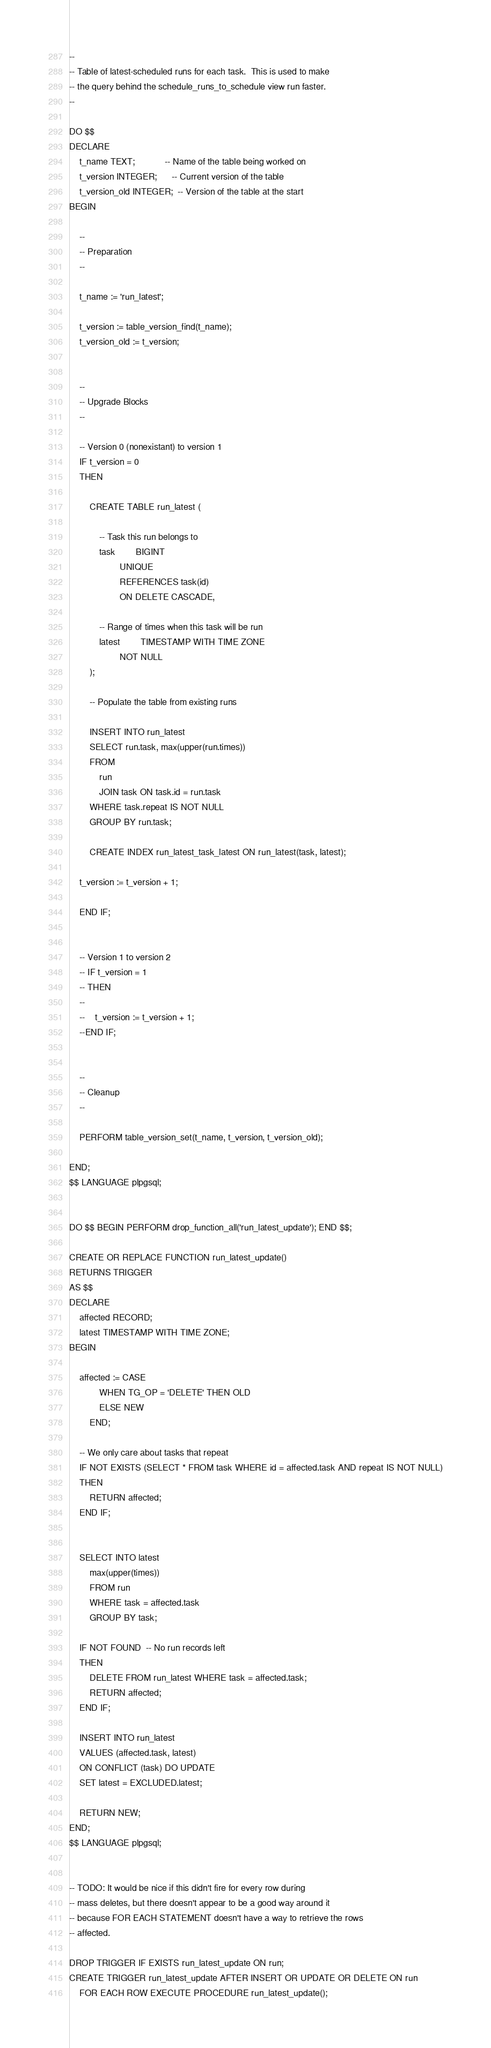Convert code to text. <code><loc_0><loc_0><loc_500><loc_500><_SQL_>--
-- Table of latest-scheduled runs for each task.  This is used to make
-- the query behind the schedule_runs_to_schedule view run faster.
--

DO $$
DECLARE
    t_name TEXT;            -- Name of the table being worked on
    t_version INTEGER;      -- Current version of the table
    t_version_old INTEGER;  -- Version of the table at the start
BEGIN

    --
    -- Preparation
    --

    t_name := 'run_latest';

    t_version := table_version_find(t_name);
    t_version_old := t_version;


    --
    -- Upgrade Blocks
    --

    -- Version 0 (nonexistant) to version 1
    IF t_version = 0
    THEN

        CREATE TABLE run_latest (

        	-- Task this run belongs to
        	task		BIGINT
        			UNIQUE
        			REFERENCES task(id)
        			ON DELETE CASCADE,

        	-- Range of times when this task will be run
        	latest		TIMESTAMP WITH TIME ZONE
        			NOT NULL
        );

        -- Populate the table from existing runs

        INSERT INTO run_latest
        SELECT run.task, max(upper(run.times))
        FROM
            run
            JOIN task ON task.id = run.task
        WHERE task.repeat IS NOT NULL
        GROUP BY run.task;

        CREATE INDEX run_latest_task_latest ON run_latest(task, latest);

	t_version := t_version + 1;

    END IF;


    -- Version 1 to version 2
    -- IF t_version = 1
    -- THEN
    --
    --    t_version := t_version + 1;
    --END IF;


    --
    -- Cleanup
    --

    PERFORM table_version_set(t_name, t_version, t_version_old);

END;
$$ LANGUAGE plpgsql;


DO $$ BEGIN PERFORM drop_function_all('run_latest_update'); END $$;

CREATE OR REPLACE FUNCTION run_latest_update()
RETURNS TRIGGER
AS $$
DECLARE
    affected RECORD;
    latest TIMESTAMP WITH TIME ZONE;
BEGIN

    affected := CASE
            WHEN TG_OP = 'DELETE' THEN OLD
            ELSE NEW
        END;

    -- We only care about tasks that repeat
    IF NOT EXISTS (SELECT * FROM task WHERE id = affected.task AND repeat IS NOT NULL)
    THEN
        RETURN affected;
    END IF;


    SELECT INTO latest
        max(upper(times))
        FROM run
        WHERE task = affected.task
        GROUP BY task;

    IF NOT FOUND  -- No run records left
    THEN
        DELETE FROM run_latest WHERE task = affected.task;
        RETURN affected;
    END IF;    

    INSERT INTO run_latest
    VALUES (affected.task, latest)
    ON CONFLICT (task) DO UPDATE
    SET latest = EXCLUDED.latest;

    RETURN NEW;
END;
$$ LANGUAGE plpgsql;


-- TODO: It would be nice if this didn't fire for every row during
-- mass deletes, but there doesn't appear to be a good way around it
-- because FOR EACH STATEMENT doesn't have a way to retrieve the rows
-- affected.

DROP TRIGGER IF EXISTS run_latest_update ON run;
CREATE TRIGGER run_latest_update AFTER INSERT OR UPDATE OR DELETE ON run
    FOR EACH ROW EXECUTE PROCEDURE run_latest_update();
</code> 